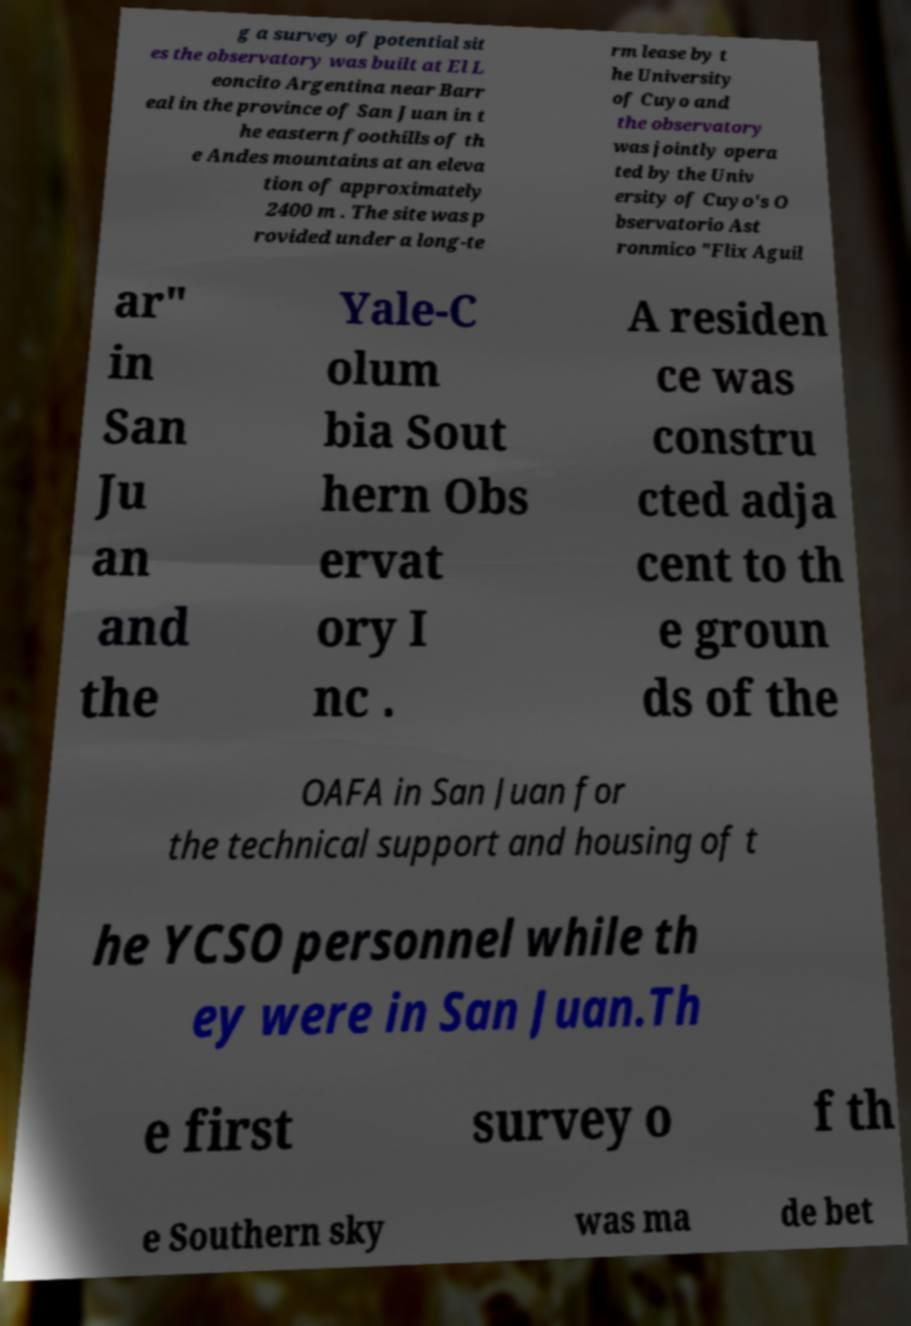Please identify and transcribe the text found in this image. g a survey of potential sit es the observatory was built at El L eoncito Argentina near Barr eal in the province of San Juan in t he eastern foothills of th e Andes mountains at an eleva tion of approximately 2400 m . The site was p rovided under a long-te rm lease by t he University of Cuyo and the observatory was jointly opera ted by the Univ ersity of Cuyo's O bservatorio Ast ronmico "Flix Aguil ar" in San Ju an and the Yale-C olum bia Sout hern Obs ervat ory I nc . A residen ce was constru cted adja cent to th e groun ds of the OAFA in San Juan for the technical support and housing of t he YCSO personnel while th ey were in San Juan.Th e first survey o f th e Southern sky was ma de bet 